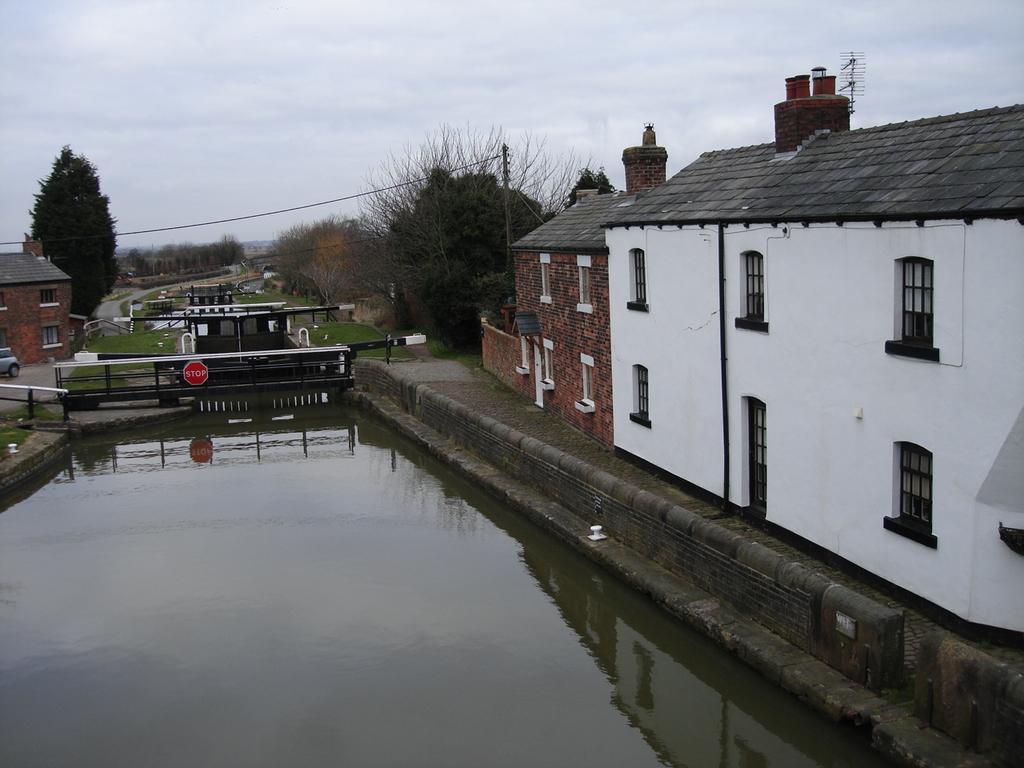How would you summarize this image in a sentence or two? This picture shows few buildings and we see trees and water and a sign board to the bridge and we see a car on the side and grass on the ground and a electrical pole. 